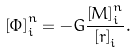<formula> <loc_0><loc_0><loc_500><loc_500>\left [ \Phi \right ] _ { i } ^ { n } = - G \frac { \left [ M \right ] ^ { n } _ { i } } { \left [ r \right ] _ { i } } .</formula> 